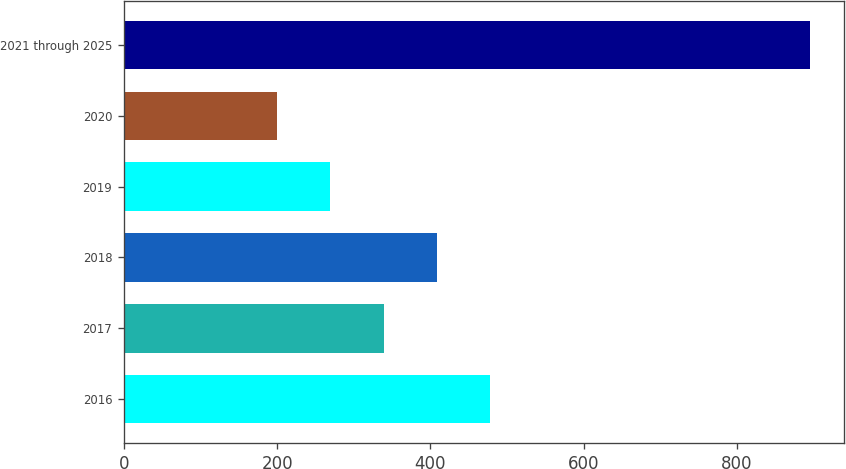Convert chart to OTSL. <chart><loc_0><loc_0><loc_500><loc_500><bar_chart><fcel>2016<fcel>2017<fcel>2018<fcel>2019<fcel>2020<fcel>2021 through 2025<nl><fcel>478<fcel>339<fcel>408.5<fcel>269.5<fcel>200<fcel>895<nl></chart> 